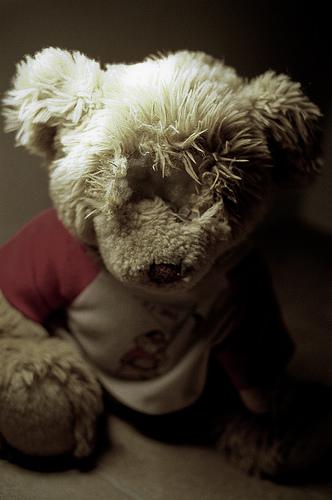What shape is the teddy bear's head?
Give a very brief answer. Round. What type of bear is this?
Quick response, please. Teddy. Is the teddy bear wearing clothes?
Keep it brief. Yes. What famous person is this toy named after?
Keep it brief. Teddy roosevelt. What color are the sleeves on the bears shirt?
Write a very short answer. Red. What does the bear wear?
Short answer required. Shirt. What does the bear's T-shirt say?
Concise answer only. Nothing. Does the bear have eyes?
Give a very brief answer. No. Is this a child's toy?
Short answer required. Yes. What color is the bears  sweater?
Concise answer only. Red and white. Is this bear going on vacation?
Short answer required. No. 